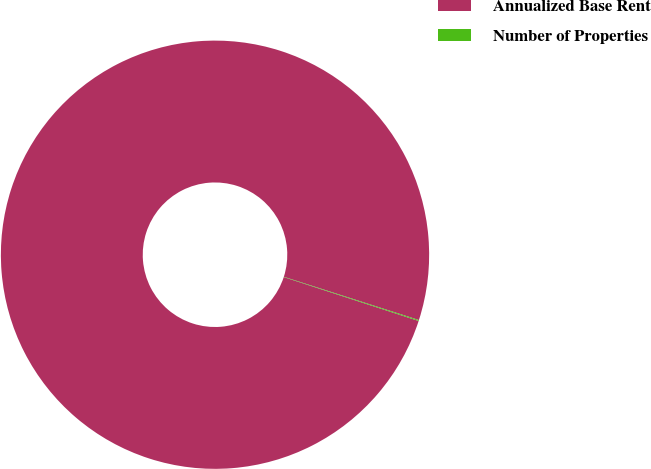Convert chart to OTSL. <chart><loc_0><loc_0><loc_500><loc_500><pie_chart><fcel>Annualized Base Rent<fcel>Number of Properties<nl><fcel>99.93%<fcel>0.07%<nl></chart> 